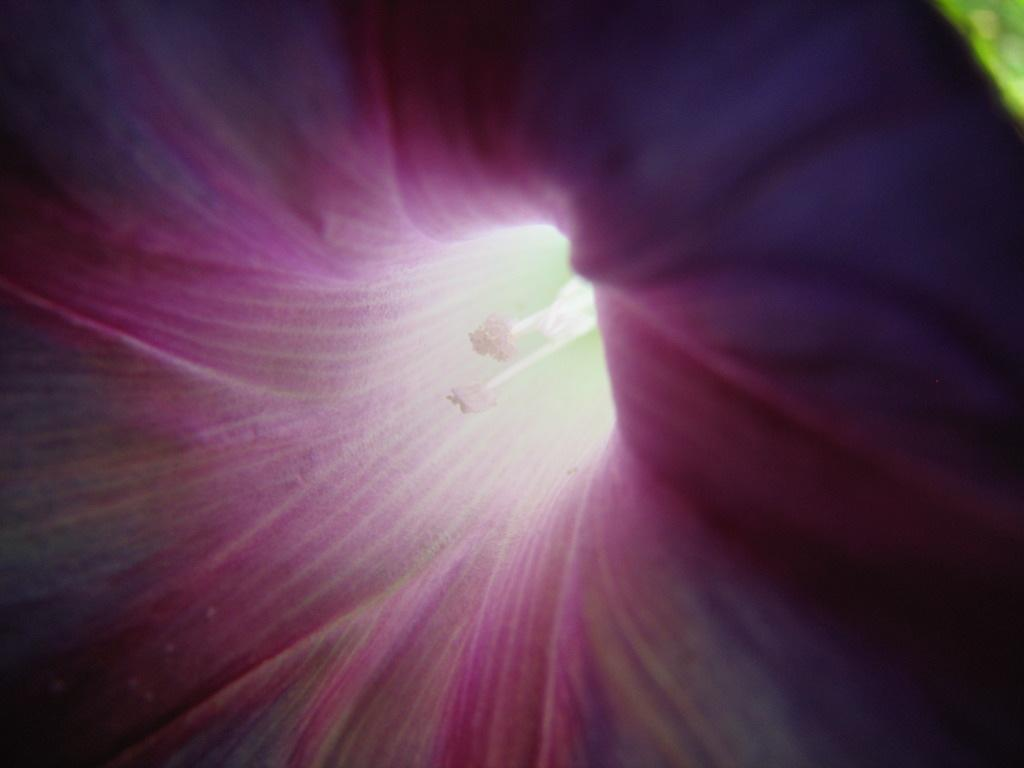What is the main subject of the image? The main subject of the image is a flower. Can you describe the viewpoint of the image? The image shows an inside view of the flower. What type of loaf can be seen in the image? There is no loaf present in the image; it features an inside view of a flower. 